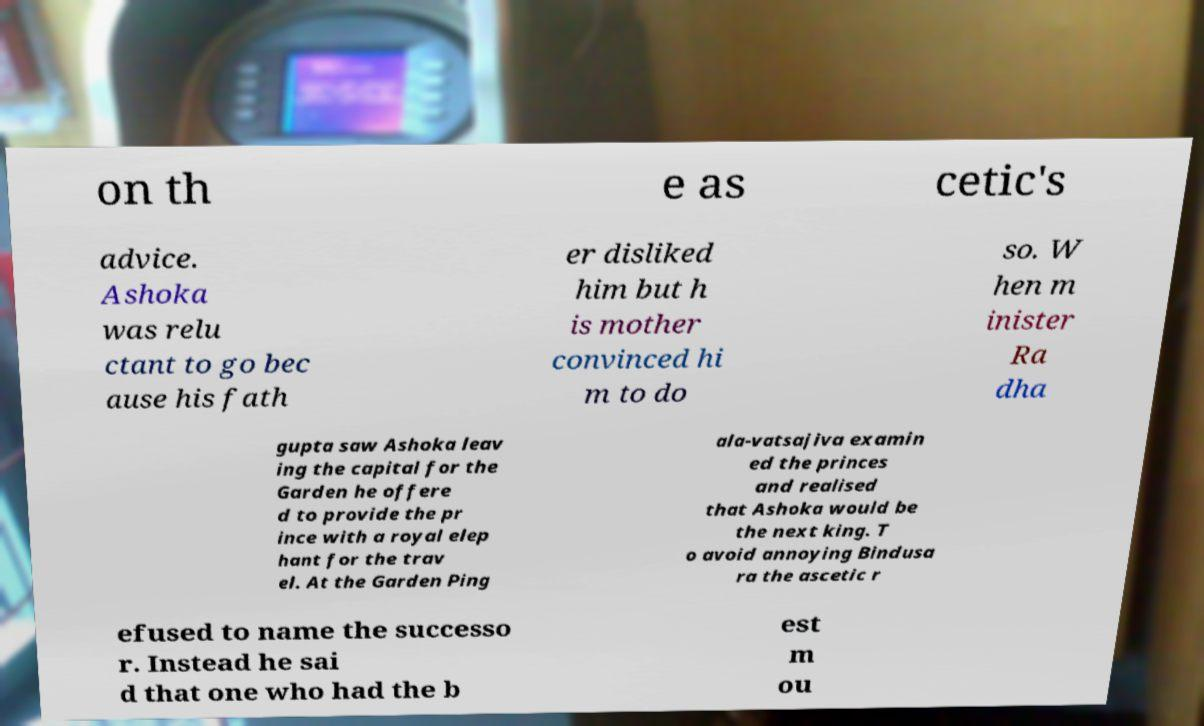Could you extract and type out the text from this image? on th e as cetic's advice. Ashoka was relu ctant to go bec ause his fath er disliked him but h is mother convinced hi m to do so. W hen m inister Ra dha gupta saw Ashoka leav ing the capital for the Garden he offere d to provide the pr ince with a royal elep hant for the trav el. At the Garden Ping ala-vatsajiva examin ed the princes and realised that Ashoka would be the next king. T o avoid annoying Bindusa ra the ascetic r efused to name the successo r. Instead he sai d that one who had the b est m ou 